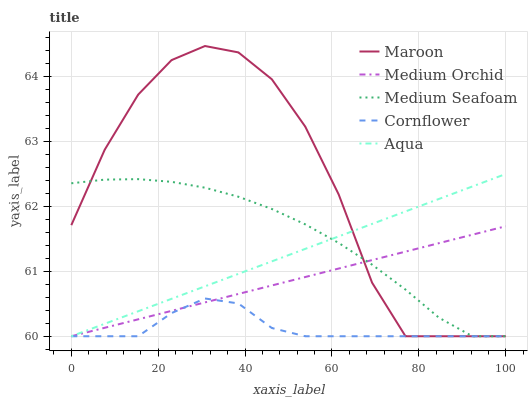Does Cornflower have the minimum area under the curve?
Answer yes or no. Yes. Does Maroon have the maximum area under the curve?
Answer yes or no. Yes. Does Medium Orchid have the minimum area under the curve?
Answer yes or no. No. Does Medium Orchid have the maximum area under the curve?
Answer yes or no. No. Is Medium Orchid the smoothest?
Answer yes or no. Yes. Is Maroon the roughest?
Answer yes or no. Yes. Is Aqua the smoothest?
Answer yes or no. No. Is Aqua the roughest?
Answer yes or no. No. Does Medium Orchid have the highest value?
Answer yes or no. No. 